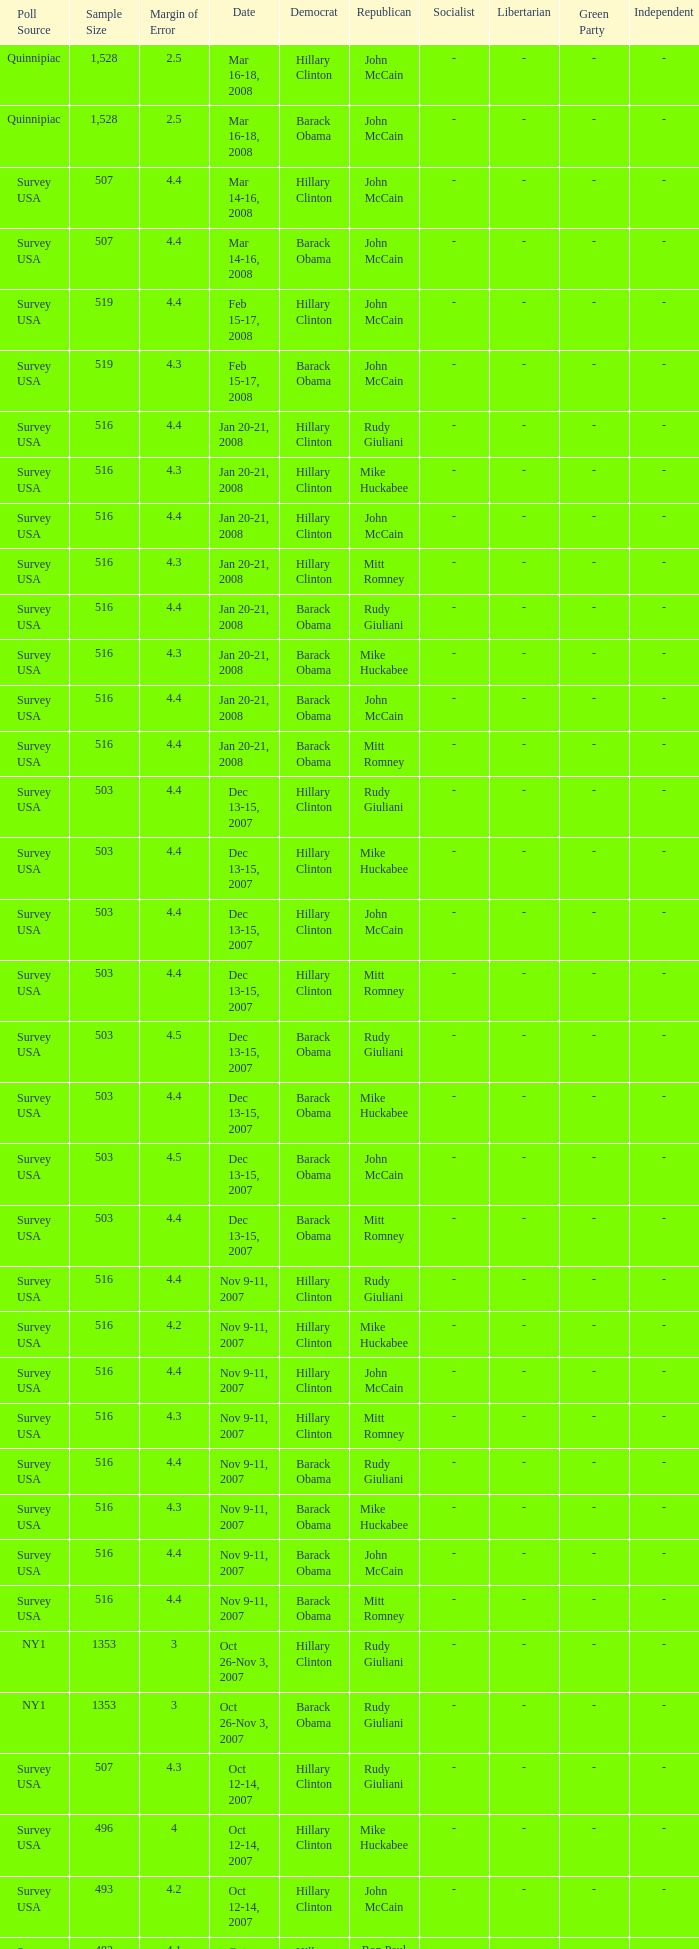What is the sample size of the poll taken on Dec 13-15, 2007 that had a margin of error of more than 4 and resulted with Republican Mike Huckabee? 503.0. 